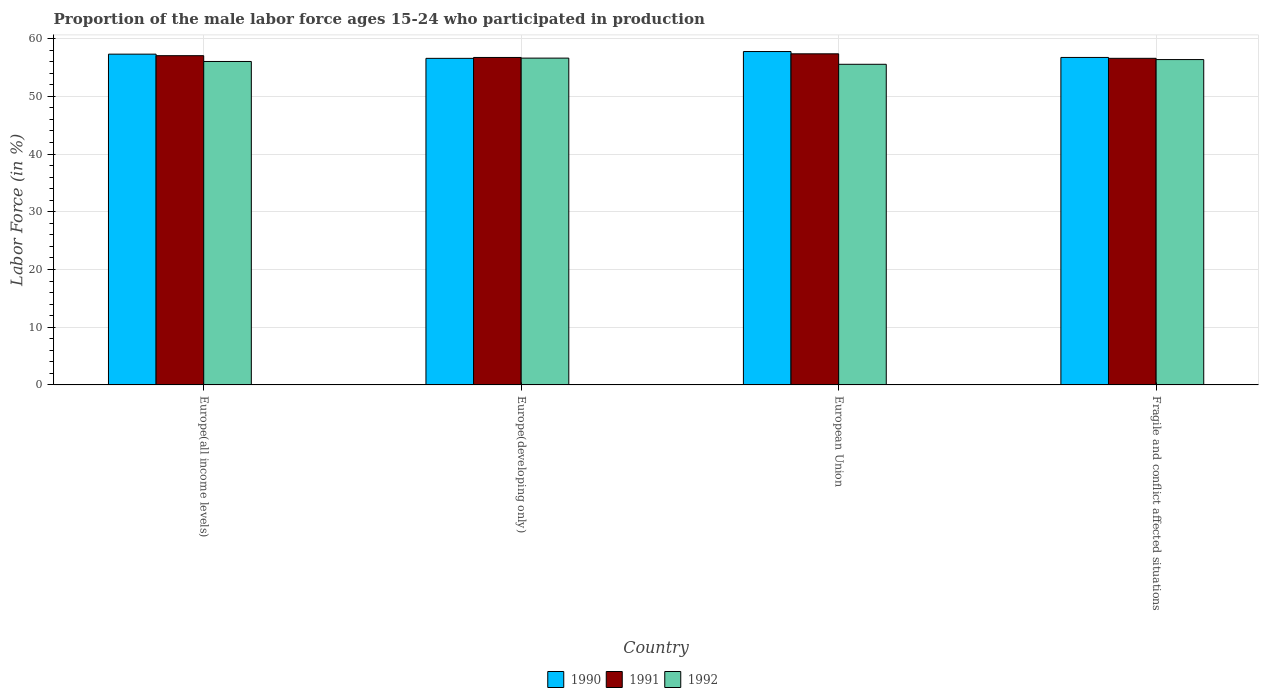How many different coloured bars are there?
Offer a very short reply. 3. Are the number of bars on each tick of the X-axis equal?
Make the answer very short. Yes. How many bars are there on the 4th tick from the left?
Your response must be concise. 3. What is the proportion of the male labor force who participated in production in 1991 in Europe(developing only)?
Make the answer very short. 56.73. Across all countries, what is the maximum proportion of the male labor force who participated in production in 1992?
Your response must be concise. 56.62. Across all countries, what is the minimum proportion of the male labor force who participated in production in 1992?
Your answer should be very brief. 55.55. In which country was the proportion of the male labor force who participated in production in 1990 maximum?
Offer a very short reply. European Union. In which country was the proportion of the male labor force who participated in production in 1990 minimum?
Your answer should be compact. Europe(developing only). What is the total proportion of the male labor force who participated in production in 1991 in the graph?
Your answer should be very brief. 227.73. What is the difference between the proportion of the male labor force who participated in production in 1991 in European Union and that in Fragile and conflict affected situations?
Give a very brief answer. 0.78. What is the difference between the proportion of the male labor force who participated in production in 1991 in Europe(all income levels) and the proportion of the male labor force who participated in production in 1990 in Europe(developing only)?
Provide a short and direct response. 0.46. What is the average proportion of the male labor force who participated in production in 1991 per country?
Provide a short and direct response. 56.93. What is the difference between the proportion of the male labor force who participated in production of/in 1990 and proportion of the male labor force who participated in production of/in 1991 in Europe(developing only)?
Make the answer very short. -0.15. In how many countries, is the proportion of the male labor force who participated in production in 1990 greater than 38 %?
Give a very brief answer. 4. What is the ratio of the proportion of the male labor force who participated in production in 1991 in Europe(developing only) to that in Fragile and conflict affected situations?
Offer a terse response. 1. Is the difference between the proportion of the male labor force who participated in production in 1990 in Europe(developing only) and European Union greater than the difference between the proportion of the male labor force who participated in production in 1991 in Europe(developing only) and European Union?
Give a very brief answer. No. What is the difference between the highest and the second highest proportion of the male labor force who participated in production in 1991?
Make the answer very short. -0.63. What is the difference between the highest and the lowest proportion of the male labor force who participated in production in 1991?
Provide a short and direct response. 0.78. Is the sum of the proportion of the male labor force who participated in production in 1991 in Europe(all income levels) and Europe(developing only) greater than the maximum proportion of the male labor force who participated in production in 1990 across all countries?
Offer a very short reply. Yes. Is it the case that in every country, the sum of the proportion of the male labor force who participated in production in 1990 and proportion of the male labor force who participated in production in 1991 is greater than the proportion of the male labor force who participated in production in 1992?
Provide a short and direct response. Yes. How many countries are there in the graph?
Your response must be concise. 4. What is the difference between two consecutive major ticks on the Y-axis?
Provide a succinct answer. 10. Where does the legend appear in the graph?
Provide a short and direct response. Bottom center. What is the title of the graph?
Offer a very short reply. Proportion of the male labor force ages 15-24 who participated in production. What is the label or title of the Y-axis?
Ensure brevity in your answer.  Labor Force (in %). What is the Labor Force (in %) in 1990 in Europe(all income levels)?
Offer a very short reply. 57.31. What is the Labor Force (in %) of 1991 in Europe(all income levels)?
Offer a very short reply. 57.04. What is the Labor Force (in %) of 1992 in Europe(all income levels)?
Your answer should be very brief. 56.04. What is the Labor Force (in %) in 1990 in Europe(developing only)?
Your response must be concise. 56.58. What is the Labor Force (in %) in 1991 in Europe(developing only)?
Provide a succinct answer. 56.73. What is the Labor Force (in %) in 1992 in Europe(developing only)?
Keep it short and to the point. 56.62. What is the Labor Force (in %) of 1990 in European Union?
Ensure brevity in your answer.  57.76. What is the Labor Force (in %) in 1991 in European Union?
Make the answer very short. 57.37. What is the Labor Force (in %) of 1992 in European Union?
Offer a terse response. 55.55. What is the Labor Force (in %) of 1990 in Fragile and conflict affected situations?
Offer a very short reply. 56.74. What is the Labor Force (in %) in 1991 in Fragile and conflict affected situations?
Provide a short and direct response. 56.59. What is the Labor Force (in %) of 1992 in Fragile and conflict affected situations?
Your response must be concise. 56.37. Across all countries, what is the maximum Labor Force (in %) in 1990?
Your answer should be very brief. 57.76. Across all countries, what is the maximum Labor Force (in %) of 1991?
Keep it short and to the point. 57.37. Across all countries, what is the maximum Labor Force (in %) of 1992?
Make the answer very short. 56.62. Across all countries, what is the minimum Labor Force (in %) of 1990?
Make the answer very short. 56.58. Across all countries, what is the minimum Labor Force (in %) of 1991?
Provide a succinct answer. 56.59. Across all countries, what is the minimum Labor Force (in %) of 1992?
Keep it short and to the point. 55.55. What is the total Labor Force (in %) in 1990 in the graph?
Your answer should be compact. 228.38. What is the total Labor Force (in %) of 1991 in the graph?
Keep it short and to the point. 227.73. What is the total Labor Force (in %) in 1992 in the graph?
Your answer should be compact. 224.58. What is the difference between the Labor Force (in %) of 1990 in Europe(all income levels) and that in Europe(developing only)?
Ensure brevity in your answer.  0.73. What is the difference between the Labor Force (in %) in 1991 in Europe(all income levels) and that in Europe(developing only)?
Provide a short and direct response. 0.31. What is the difference between the Labor Force (in %) in 1992 in Europe(all income levels) and that in Europe(developing only)?
Offer a terse response. -0.58. What is the difference between the Labor Force (in %) of 1990 in Europe(all income levels) and that in European Union?
Provide a short and direct response. -0.45. What is the difference between the Labor Force (in %) of 1991 in Europe(all income levels) and that in European Union?
Provide a succinct answer. -0.32. What is the difference between the Labor Force (in %) in 1992 in Europe(all income levels) and that in European Union?
Your response must be concise. 0.49. What is the difference between the Labor Force (in %) in 1990 in Europe(all income levels) and that in Fragile and conflict affected situations?
Provide a succinct answer. 0.57. What is the difference between the Labor Force (in %) in 1991 in Europe(all income levels) and that in Fragile and conflict affected situations?
Ensure brevity in your answer.  0.46. What is the difference between the Labor Force (in %) of 1992 in Europe(all income levels) and that in Fragile and conflict affected situations?
Offer a terse response. -0.33. What is the difference between the Labor Force (in %) of 1990 in Europe(developing only) and that in European Union?
Provide a short and direct response. -1.18. What is the difference between the Labor Force (in %) of 1991 in Europe(developing only) and that in European Union?
Keep it short and to the point. -0.63. What is the difference between the Labor Force (in %) of 1992 in Europe(developing only) and that in European Union?
Provide a short and direct response. 1.07. What is the difference between the Labor Force (in %) in 1990 in Europe(developing only) and that in Fragile and conflict affected situations?
Your answer should be compact. -0.16. What is the difference between the Labor Force (in %) of 1991 in Europe(developing only) and that in Fragile and conflict affected situations?
Keep it short and to the point. 0.15. What is the difference between the Labor Force (in %) in 1990 in European Union and that in Fragile and conflict affected situations?
Provide a short and direct response. 1.02. What is the difference between the Labor Force (in %) of 1991 in European Union and that in Fragile and conflict affected situations?
Offer a terse response. 0.78. What is the difference between the Labor Force (in %) in 1992 in European Union and that in Fragile and conflict affected situations?
Your answer should be very brief. -0.82. What is the difference between the Labor Force (in %) in 1990 in Europe(all income levels) and the Labor Force (in %) in 1991 in Europe(developing only)?
Your response must be concise. 0.58. What is the difference between the Labor Force (in %) of 1990 in Europe(all income levels) and the Labor Force (in %) of 1992 in Europe(developing only)?
Your answer should be compact. 0.69. What is the difference between the Labor Force (in %) in 1991 in Europe(all income levels) and the Labor Force (in %) in 1992 in Europe(developing only)?
Provide a short and direct response. 0.42. What is the difference between the Labor Force (in %) of 1990 in Europe(all income levels) and the Labor Force (in %) of 1991 in European Union?
Offer a very short reply. -0.06. What is the difference between the Labor Force (in %) of 1990 in Europe(all income levels) and the Labor Force (in %) of 1992 in European Union?
Your answer should be very brief. 1.76. What is the difference between the Labor Force (in %) of 1991 in Europe(all income levels) and the Labor Force (in %) of 1992 in European Union?
Offer a terse response. 1.49. What is the difference between the Labor Force (in %) in 1990 in Europe(all income levels) and the Labor Force (in %) in 1991 in Fragile and conflict affected situations?
Ensure brevity in your answer.  0.72. What is the difference between the Labor Force (in %) in 1990 in Europe(all income levels) and the Labor Force (in %) in 1992 in Fragile and conflict affected situations?
Ensure brevity in your answer.  0.94. What is the difference between the Labor Force (in %) in 1991 in Europe(all income levels) and the Labor Force (in %) in 1992 in Fragile and conflict affected situations?
Offer a terse response. 0.67. What is the difference between the Labor Force (in %) in 1990 in Europe(developing only) and the Labor Force (in %) in 1991 in European Union?
Give a very brief answer. -0.79. What is the difference between the Labor Force (in %) of 1990 in Europe(developing only) and the Labor Force (in %) of 1992 in European Union?
Give a very brief answer. 1.03. What is the difference between the Labor Force (in %) in 1991 in Europe(developing only) and the Labor Force (in %) in 1992 in European Union?
Provide a short and direct response. 1.18. What is the difference between the Labor Force (in %) of 1990 in Europe(developing only) and the Labor Force (in %) of 1991 in Fragile and conflict affected situations?
Your response must be concise. -0.01. What is the difference between the Labor Force (in %) in 1990 in Europe(developing only) and the Labor Force (in %) in 1992 in Fragile and conflict affected situations?
Keep it short and to the point. 0.21. What is the difference between the Labor Force (in %) of 1991 in Europe(developing only) and the Labor Force (in %) of 1992 in Fragile and conflict affected situations?
Offer a very short reply. 0.36. What is the difference between the Labor Force (in %) in 1990 in European Union and the Labor Force (in %) in 1991 in Fragile and conflict affected situations?
Provide a short and direct response. 1.17. What is the difference between the Labor Force (in %) of 1990 in European Union and the Labor Force (in %) of 1992 in Fragile and conflict affected situations?
Provide a short and direct response. 1.39. What is the average Labor Force (in %) in 1990 per country?
Ensure brevity in your answer.  57.1. What is the average Labor Force (in %) in 1991 per country?
Give a very brief answer. 56.93. What is the average Labor Force (in %) of 1992 per country?
Your answer should be very brief. 56.14. What is the difference between the Labor Force (in %) of 1990 and Labor Force (in %) of 1991 in Europe(all income levels)?
Offer a very short reply. 0.27. What is the difference between the Labor Force (in %) of 1990 and Labor Force (in %) of 1992 in Europe(all income levels)?
Make the answer very short. 1.27. What is the difference between the Labor Force (in %) in 1990 and Labor Force (in %) in 1991 in Europe(developing only)?
Ensure brevity in your answer.  -0.15. What is the difference between the Labor Force (in %) of 1990 and Labor Force (in %) of 1992 in Europe(developing only)?
Give a very brief answer. -0.04. What is the difference between the Labor Force (in %) of 1991 and Labor Force (in %) of 1992 in Europe(developing only)?
Provide a short and direct response. 0.11. What is the difference between the Labor Force (in %) of 1990 and Labor Force (in %) of 1991 in European Union?
Offer a very short reply. 0.39. What is the difference between the Labor Force (in %) of 1990 and Labor Force (in %) of 1992 in European Union?
Ensure brevity in your answer.  2.21. What is the difference between the Labor Force (in %) of 1991 and Labor Force (in %) of 1992 in European Union?
Give a very brief answer. 1.82. What is the difference between the Labor Force (in %) in 1990 and Labor Force (in %) in 1991 in Fragile and conflict affected situations?
Provide a succinct answer. 0.15. What is the difference between the Labor Force (in %) of 1990 and Labor Force (in %) of 1992 in Fragile and conflict affected situations?
Your response must be concise. 0.37. What is the difference between the Labor Force (in %) in 1991 and Labor Force (in %) in 1992 in Fragile and conflict affected situations?
Your answer should be very brief. 0.22. What is the ratio of the Labor Force (in %) of 1990 in Europe(all income levels) to that in Europe(developing only)?
Offer a terse response. 1.01. What is the ratio of the Labor Force (in %) in 1991 in Europe(all income levels) to that in Europe(developing only)?
Keep it short and to the point. 1.01. What is the ratio of the Labor Force (in %) of 1992 in Europe(all income levels) to that in Europe(developing only)?
Your answer should be very brief. 0.99. What is the ratio of the Labor Force (in %) of 1991 in Europe(all income levels) to that in European Union?
Keep it short and to the point. 0.99. What is the ratio of the Labor Force (in %) of 1992 in Europe(all income levels) to that in European Union?
Your answer should be compact. 1.01. What is the ratio of the Labor Force (in %) of 1990 in Europe(developing only) to that in European Union?
Your response must be concise. 0.98. What is the ratio of the Labor Force (in %) in 1992 in Europe(developing only) to that in European Union?
Your answer should be compact. 1.02. What is the ratio of the Labor Force (in %) of 1992 in Europe(developing only) to that in Fragile and conflict affected situations?
Offer a terse response. 1. What is the ratio of the Labor Force (in %) of 1990 in European Union to that in Fragile and conflict affected situations?
Offer a very short reply. 1.02. What is the ratio of the Labor Force (in %) of 1991 in European Union to that in Fragile and conflict affected situations?
Offer a very short reply. 1.01. What is the ratio of the Labor Force (in %) in 1992 in European Union to that in Fragile and conflict affected situations?
Make the answer very short. 0.99. What is the difference between the highest and the second highest Labor Force (in %) of 1990?
Give a very brief answer. 0.45. What is the difference between the highest and the second highest Labor Force (in %) in 1991?
Your answer should be very brief. 0.32. What is the difference between the highest and the second highest Labor Force (in %) of 1992?
Your answer should be compact. 0.25. What is the difference between the highest and the lowest Labor Force (in %) in 1990?
Provide a succinct answer. 1.18. What is the difference between the highest and the lowest Labor Force (in %) of 1991?
Make the answer very short. 0.78. What is the difference between the highest and the lowest Labor Force (in %) of 1992?
Your answer should be compact. 1.07. 